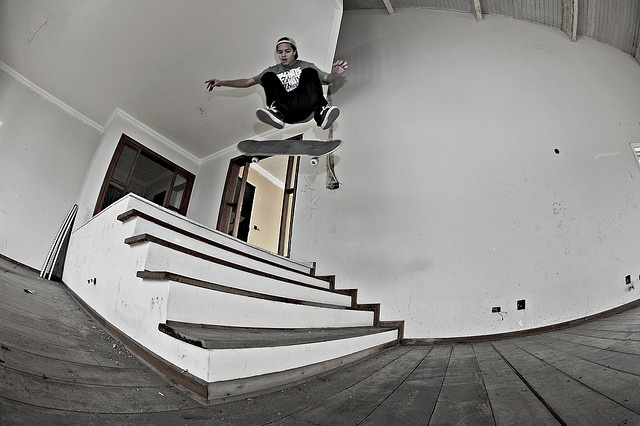Describe the objects in this image and their specific colors. I can see people in gray, black, darkgray, and lightgray tones and skateboard in gray, black, darkgray, and lightgray tones in this image. 